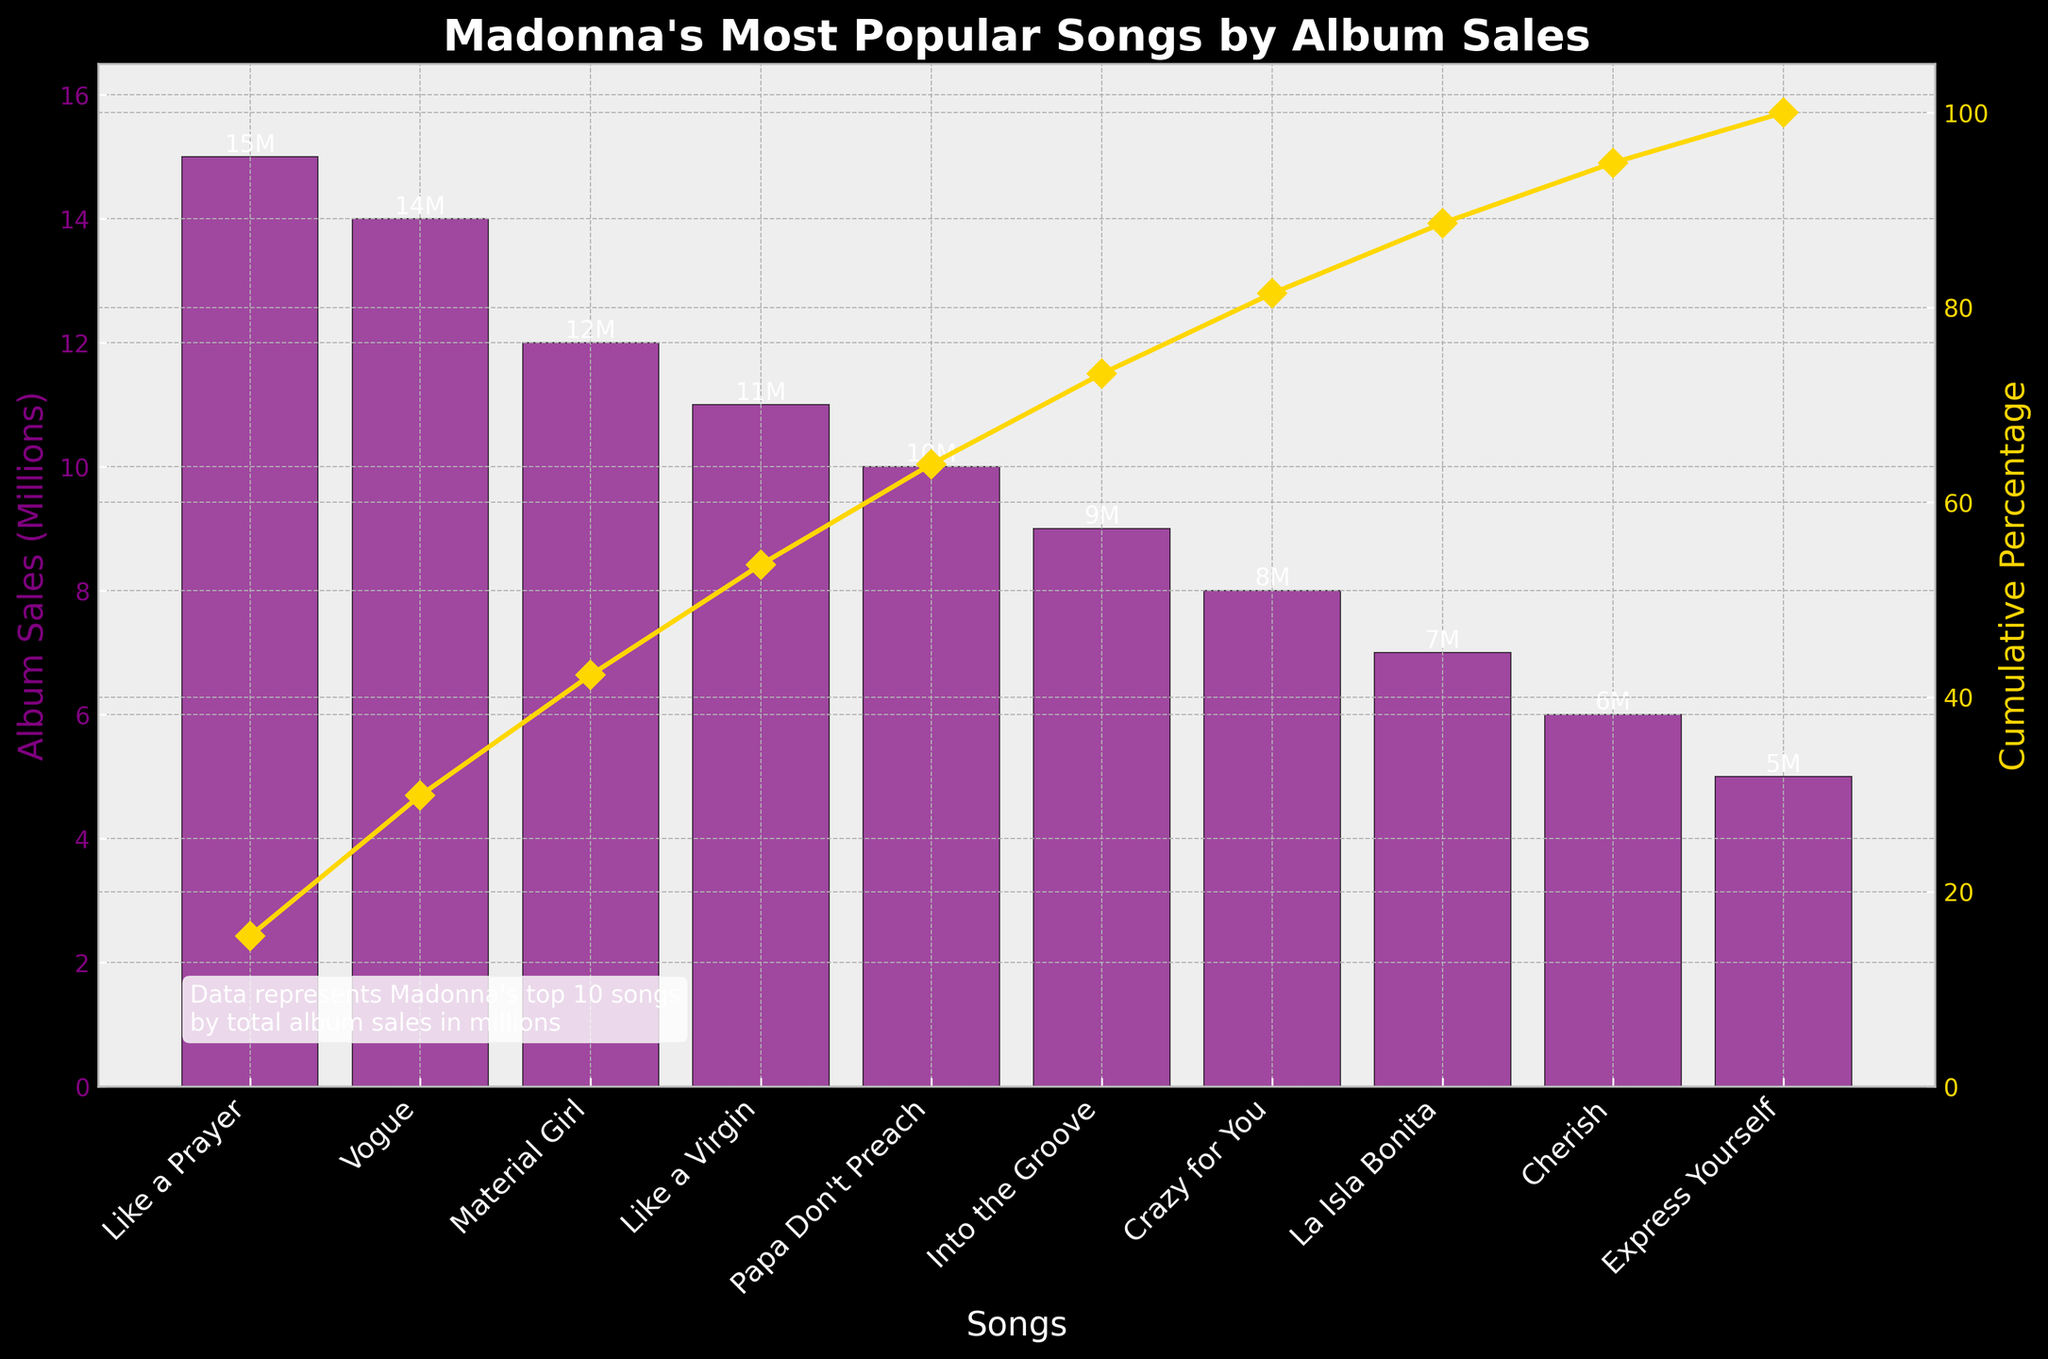what is the title of the chart? Look at the top of the figure to read the bolded heading text that describes what the chart represents.
Answer: Madonna's Most Popular Songs by Album Sales what song has the highest album sales? Find the tallest purple bar in the chart; the label below it corresponds to the song with the highest sales.
Answer: Like a Prayer what is the album sales value for "Vogue"? Look for the bar labeled "Vogue" and read the number attached to the top of that bar.
Answer: 14 million which song has sold 9 million albums? Identify the bar that reaches the 9 million mark on the y-axis, then look at the label below it.
Answer: Into the Groove what is the cumulative percentage for "Material Girl"? Find the marker on the gold line that corresponds to "Material Girl" and read the percentage value from the secondary y-axis.
Answer: 37.5% which song has a lower album sales value: "Crazy for You" or "Like a Virgin"? Compare the heights of the bars for "Crazy for You" and "Like a Virgin" to see which is shorter.
Answer: Crazy for You how many songs have sales of 10 million or more albums? Count the number of bars that reach or exceed the 10 million mark on the y-axis.
Answer: 5 which song represents the 50% cumulative percentage mark? Trace the gold cumulative percentage line to the point where it intersects 50% on the secondary y-axis; the label below indicates the song.
Answer: Papa Don't Preach what is the combined album sales for "La Isla Bonita" and "Cherish"? Add the sales values for "La Isla Bonita" (7 million) and "Cherish" (6 million).
Answer: 13 million what is the difference in album sales between "Like a Prayer" and "Express Yourself"? Subtract the album sales of "Express Yourself" (5 million) from "Like a Prayer" (15 million).
Answer: 10 million 